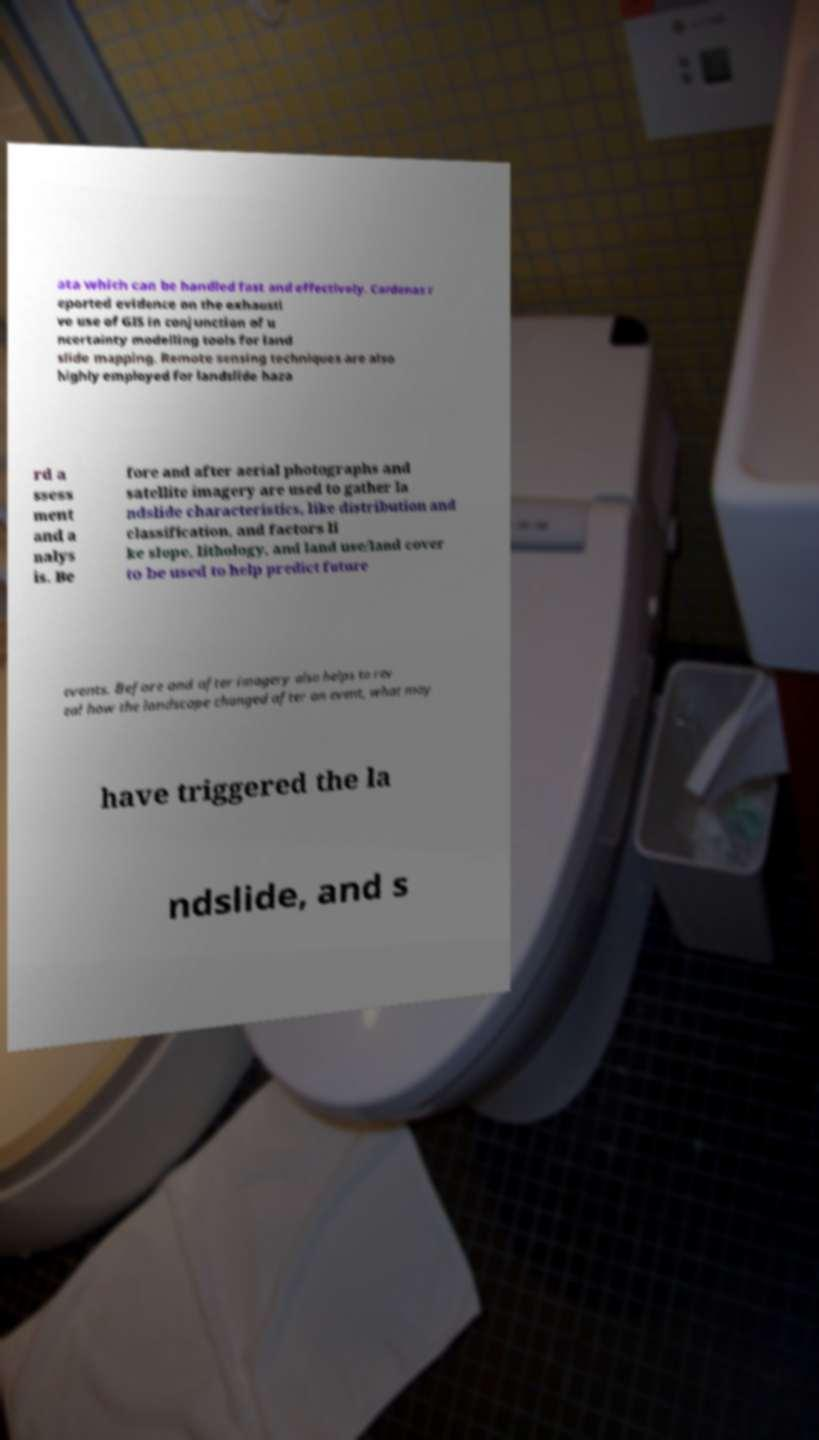Can you accurately transcribe the text from the provided image for me? ata which can be handled fast and effectively. Cardenas r eported evidence on the exhausti ve use of GIS in conjunction of u ncertainty modelling tools for land slide mapping. Remote sensing techniques are also highly employed for landslide haza rd a ssess ment and a nalys is. Be fore and after aerial photographs and satellite imagery are used to gather la ndslide characteristics, like distribution and classification, and factors li ke slope, lithology, and land use/land cover to be used to help predict future events. Before and after imagery also helps to rev eal how the landscape changed after an event, what may have triggered the la ndslide, and s 